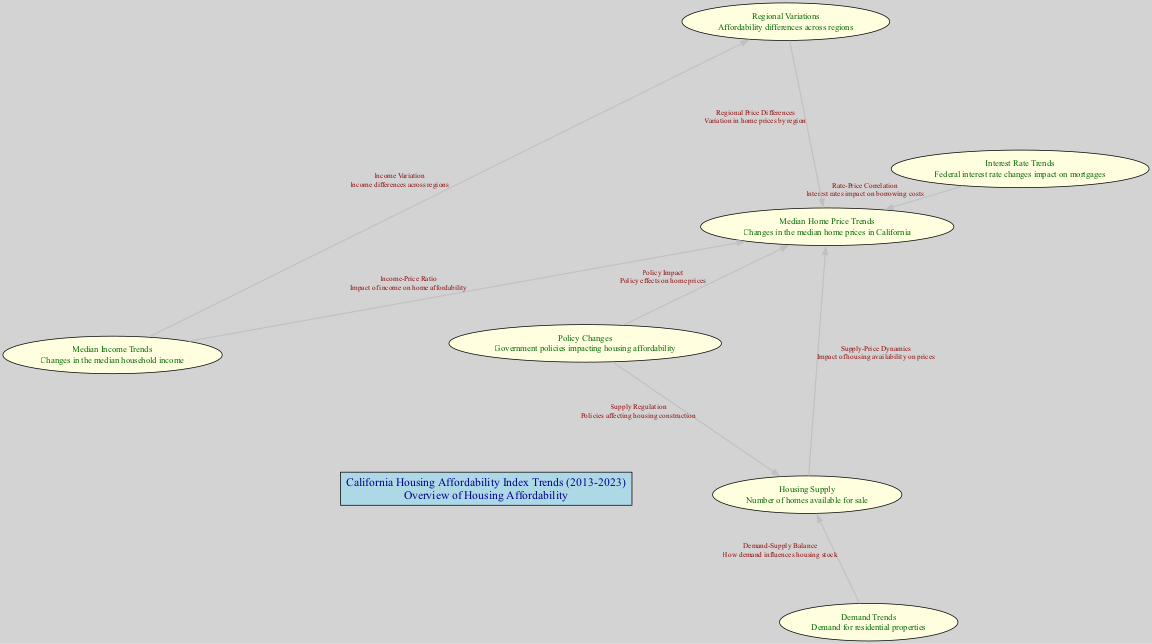What is the title of the central node? The central node is titled "California Housing Affordability Index Trends (2013-2023)". This is directly taken from the data under the 'center' section of the input.
Answer: California Housing Affordability Index Trends (2013-2023) How many nodes are in the diagram? The diagram contains seven nodes, which are each connected to the central node and illustrate various aspects of housing affordability trends. This is counted based on the number of entries in the 'nodes' section of the data.
Answer: 7 What is the primary relationship between 'interest rates' and 'median home price'? The primary relationship indicated is "Rate-Price Correlation", which describes how interest rates impact borrowing costs related to home prices, as specified in the edge connecting these two nodes.
Answer: Rate-Price Correlation Which node is connected to 'demand trends'? The node that is connected to 'demand trends' is 'housing supply'. This connection signifies the relationship between housing demand and the availability of homes for sale, as indicated in the edge connecting them.
Answer: Housing Supply What impact do policy changes have on 'median home price'? Policy changes have an impact described as "Policy Impact", which indicates how government policies influence home pricing. This relationship is specified in the edge connecting the 'policy_changes' and 'median_home_price' nodes.
Answer: Policy Impact What does the edge labeled "Income-Price Ratio" signify in the context of the diagram? The "Income-Price Ratio" signifies the impact of median income on home affordability, showing how changes in income levels correlate with median home prices. This is captured in the edge connecting 'median_income' and 'median_home_price'.
Answer: Impact of income on home affordability Is there a node that addresses regional differences in housing affordability? Yes, the node 'regional_variation' addresses regional differences. This node connects to 'median_home_price', emphasizing how home prices vary across different regions in California.
Answer: Yes How do 'policy changes' affect 'housing supply'? 'Policy changes' affect 'housing supply' through a relationship referred to as "Supply Regulation", indicating how regulations impact the construction of housing. This connection is detailed in the edge between these two nodes.
Answer: Supply Regulation What factor is represented by the 'housing supply' node in relation to 'median home price'? The 'housing supply' node represents the factor described as "Supply-Price Dynamics", illustrating how the availability of housing influences median home prices. This is indicated in the edge linking these nodes.
Answer: Supply-Price Dynamics 